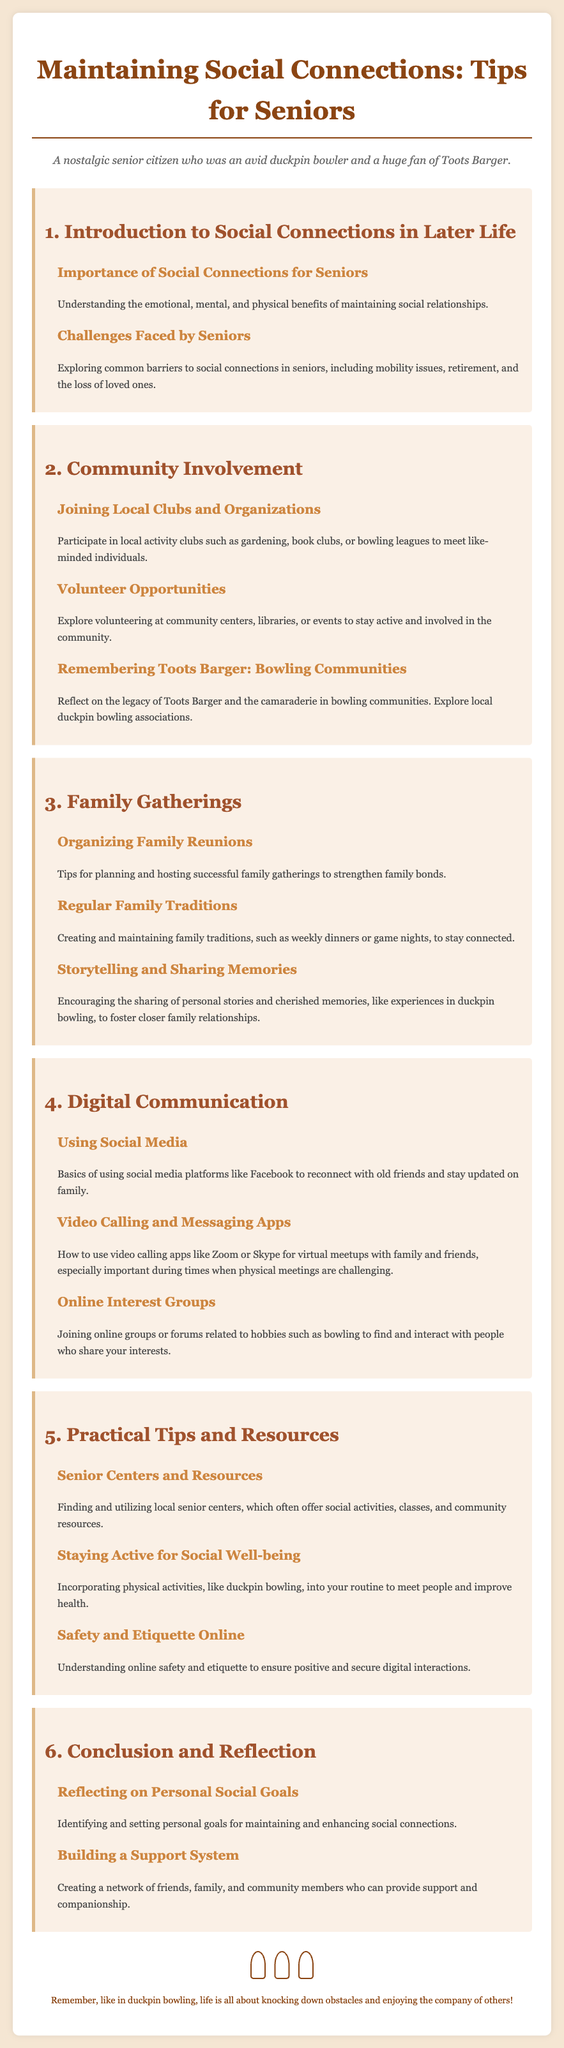What is the title of the syllabus? The title is stated at the top of the document and reflects the main topic focused on social connections for seniors.
Answer: Maintaining Social Connections: Tips for Seniors What is one of the main barriers to social connections faced by seniors? The document mentions common challenges that seniors encounter, which can include various issues.
Answer: Mobility issues What activity is suggested for connecting with like-minded individuals? The syllabus provides recommendations for community involvement and types of local activities for seniors to engage in.
Answer: Bowling leagues Which type of communication tool is highlighted for virtual meetups? The document lists specific apps that can facilitate digital face-to-face interactions, especially when physical meetings are not possible.
Answer: Zoom What is a key benefit of storytelling mentioned in the syllabus? The document elaborates on how sharing personal stories can enhance familial ties and strengthen relationships.
Answer: Foster closer family relationships What should seniors do to enhance social connections according to the conclusion section? The reflection section encourages seniors to set specific objectives related to their social lives, which is essential for improvement.
Answer: Identify and set personal goals What type of community resource is mentioned for seniors? The syllabus outlines resources available to seniors which can support their social activities and engagements.
Answer: Senior centers What sentiment about bowling is expressed in the document? The footer reiterates the importance of camaraderie and community found through bowling, echoing its significance in social interactions.
Answer: Enjoying the company of others 